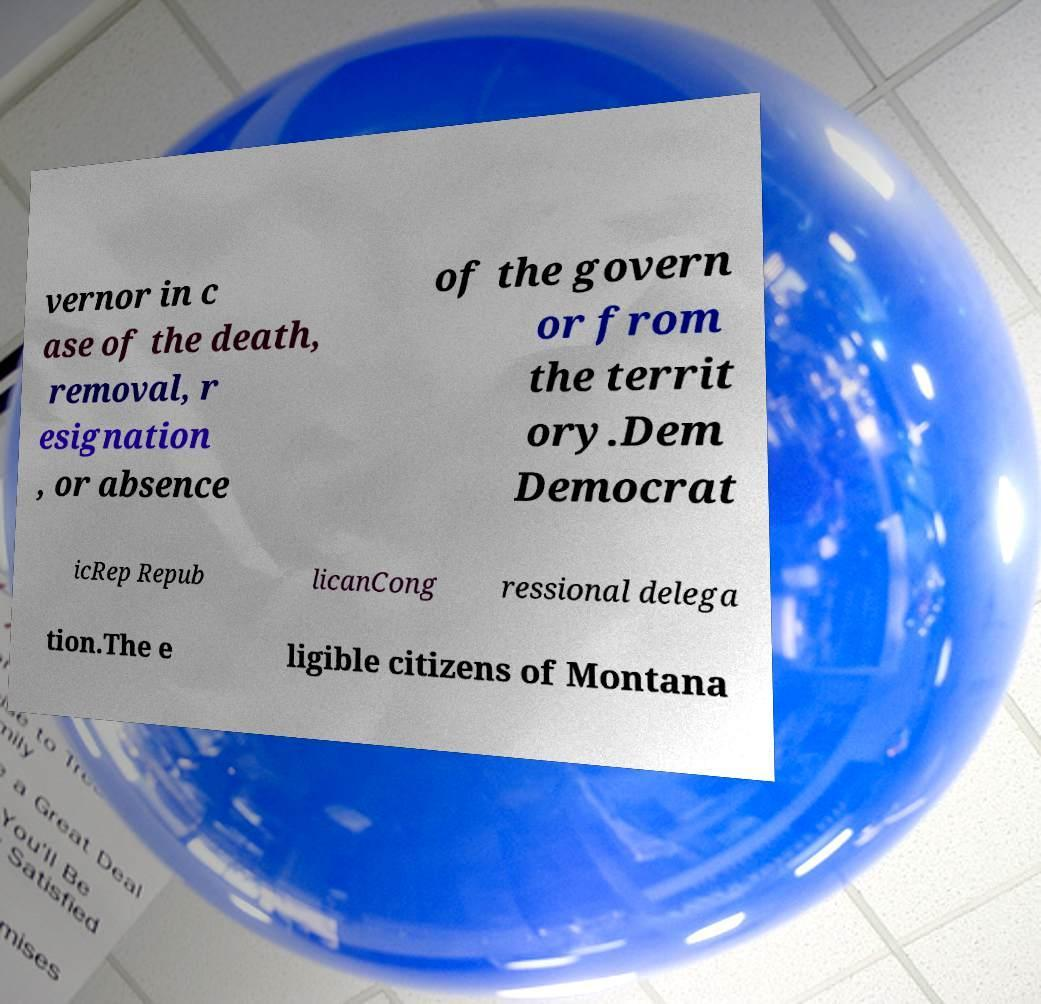There's text embedded in this image that I need extracted. Can you transcribe it verbatim? vernor in c ase of the death, removal, r esignation , or absence of the govern or from the territ ory.Dem Democrat icRep Repub licanCong ressional delega tion.The e ligible citizens of Montana 